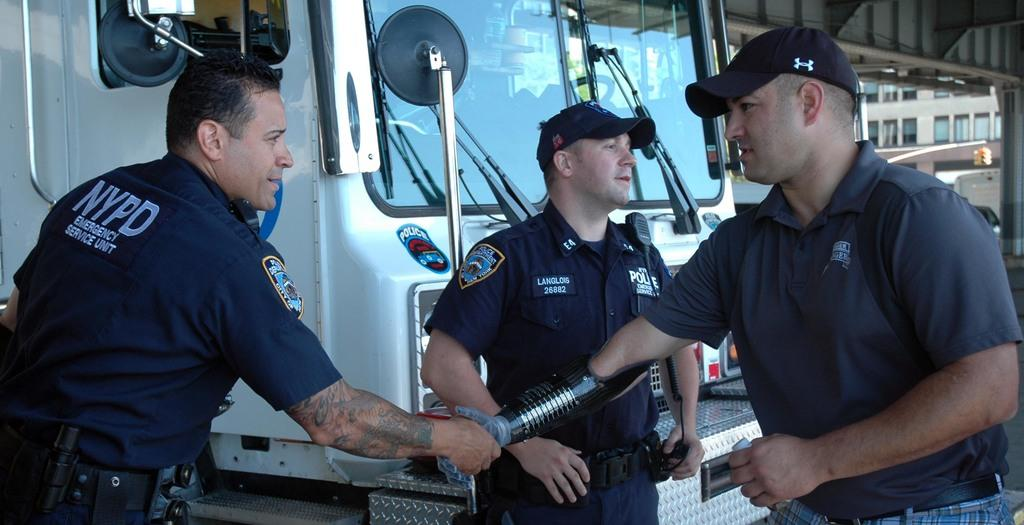How many men are present in the image? There are two men in the image. What are the two men doing in the image? The two men are looking at each other and shaking hands. Can you describe the scene in the background of the image? There is another man and a truck in the background of the image. How many women are present in the image? There are no women present in the image. What is the color of the crib in the image? There is no crib present in the image. 